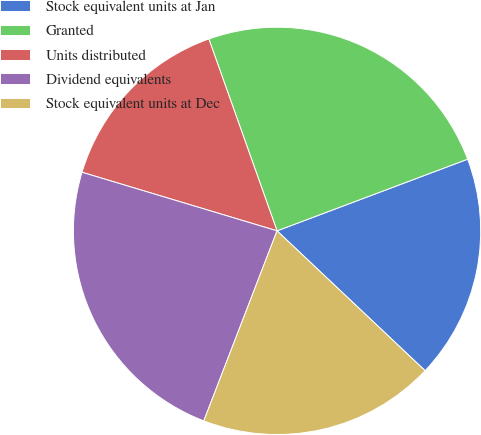Convert chart to OTSL. <chart><loc_0><loc_0><loc_500><loc_500><pie_chart><fcel>Stock equivalent units at Jan<fcel>Granted<fcel>Units distributed<fcel>Dividend equivalents<fcel>Stock equivalent units at Dec<nl><fcel>17.77%<fcel>24.71%<fcel>14.92%<fcel>23.79%<fcel>18.81%<nl></chart> 